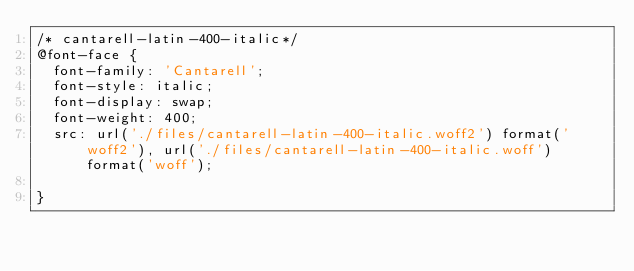Convert code to text. <code><loc_0><loc_0><loc_500><loc_500><_CSS_>/* cantarell-latin-400-italic*/
@font-face {
  font-family: 'Cantarell';
  font-style: italic;
  font-display: swap;
  font-weight: 400;
  src: url('./files/cantarell-latin-400-italic.woff2') format('woff2'), url('./files/cantarell-latin-400-italic.woff') format('woff');
  
}
</code> 